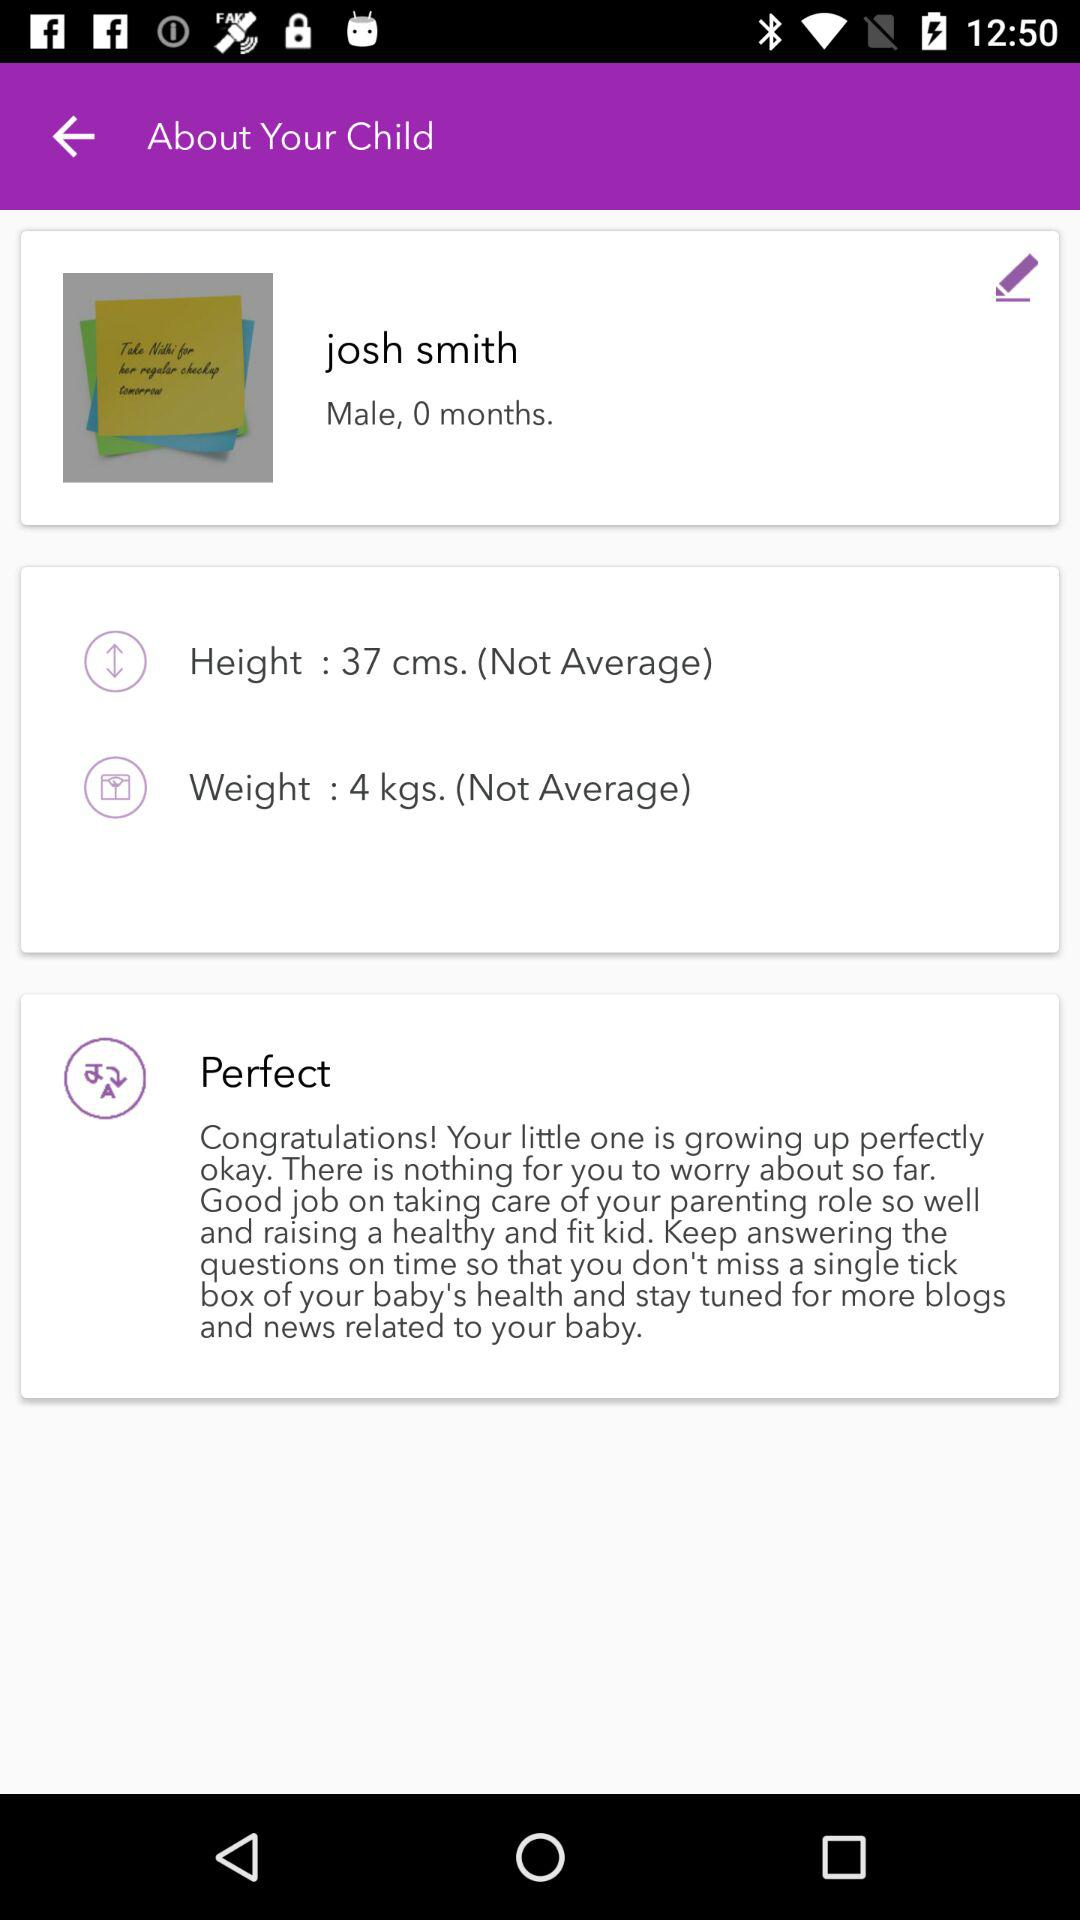How many months old is Josh Smith?
Answer the question using a single word or phrase. 0 months 